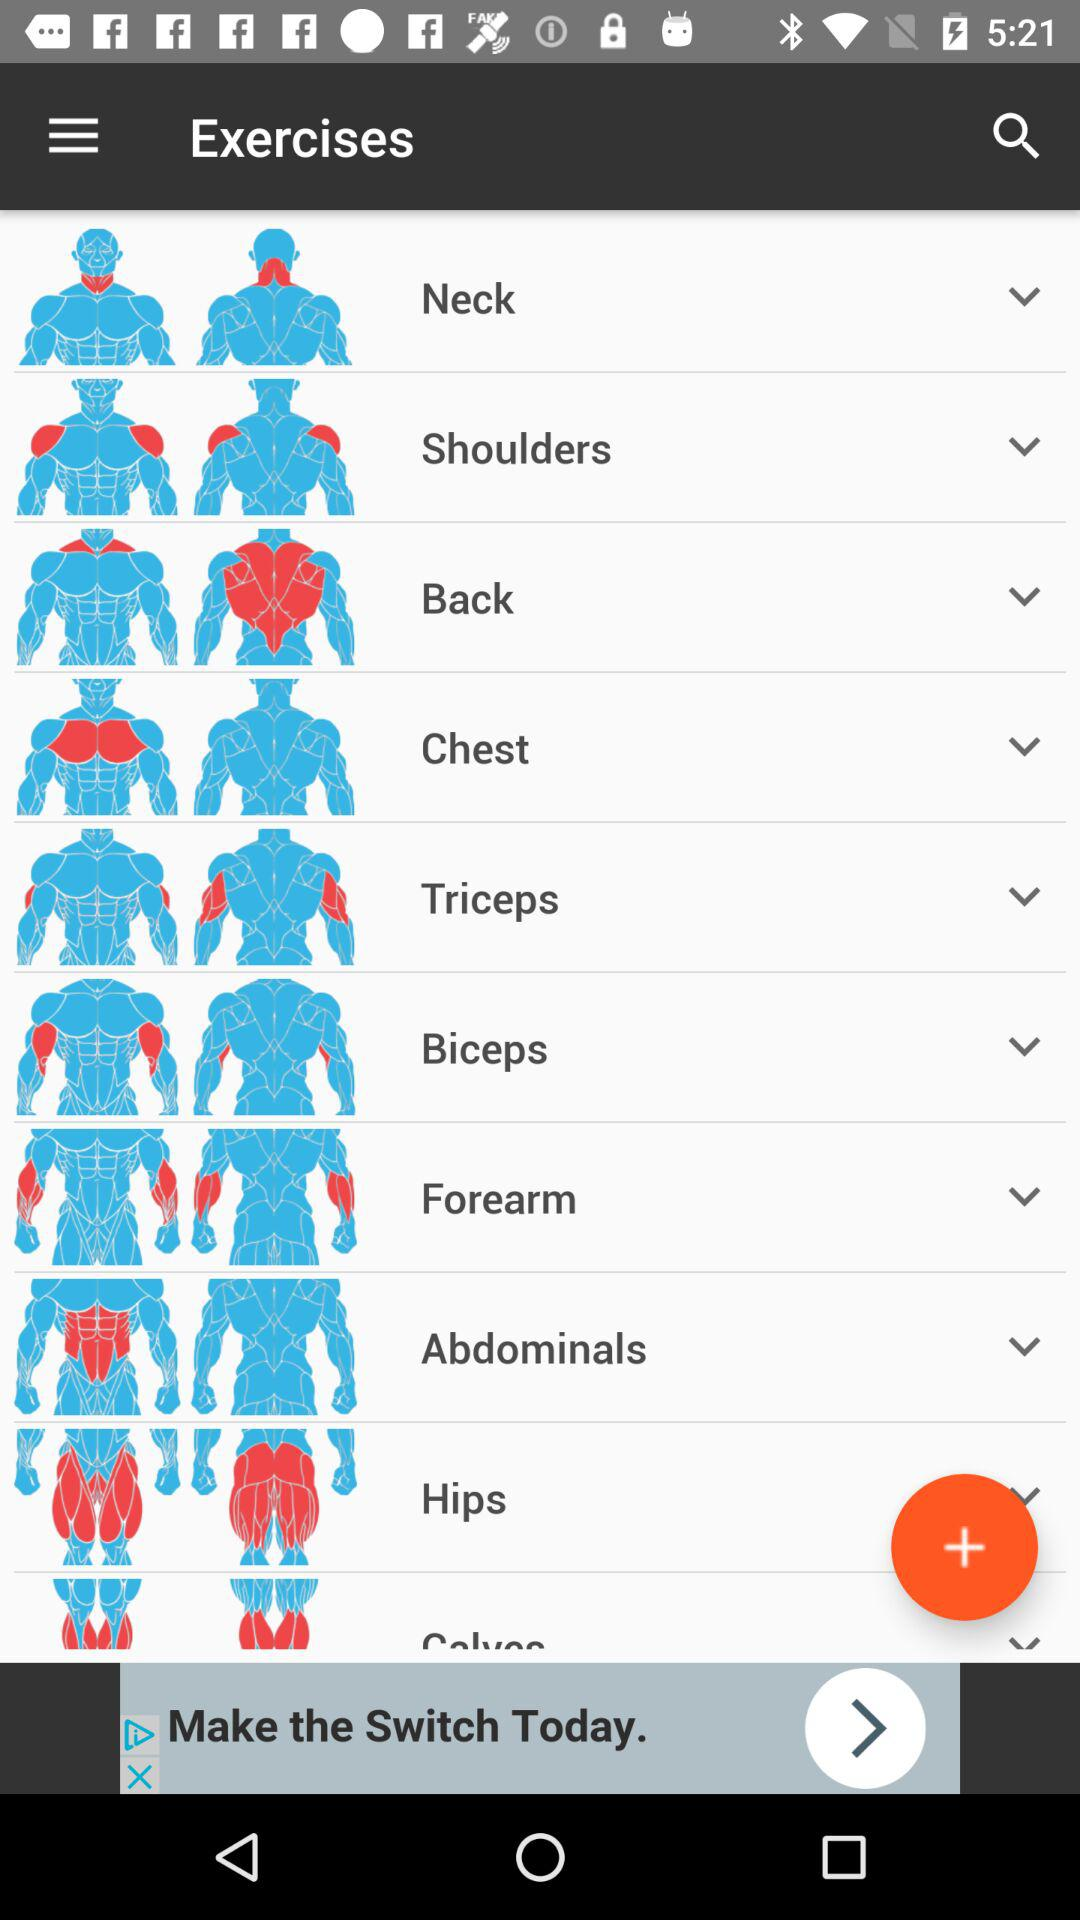What are the available options for exercise? The available options for exercise are neck, shoulders, back, chest, triceps, biceps, forearm, abdominals and hips. 